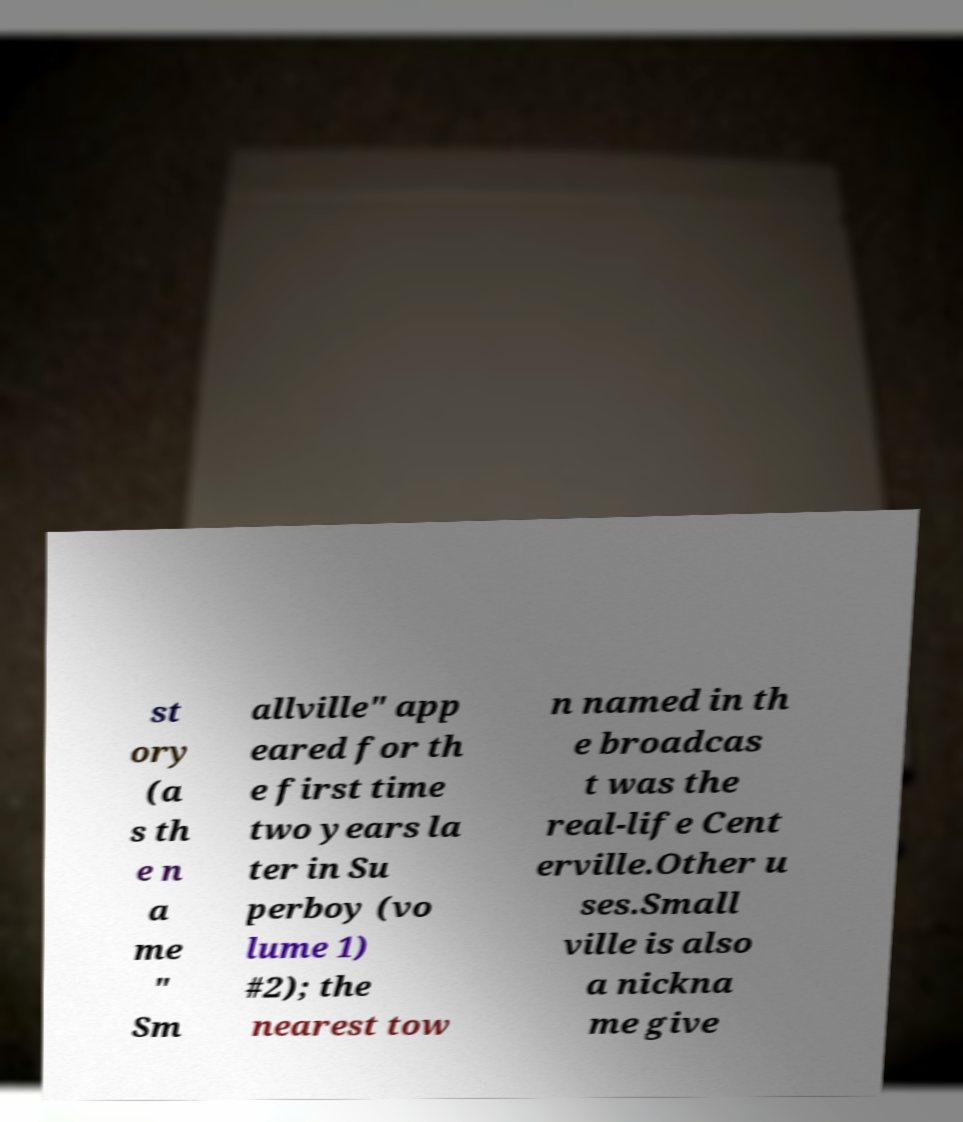Please identify and transcribe the text found in this image. st ory (a s th e n a me " Sm allville" app eared for th e first time two years la ter in Su perboy (vo lume 1) #2); the nearest tow n named in th e broadcas t was the real-life Cent erville.Other u ses.Small ville is also a nickna me give 